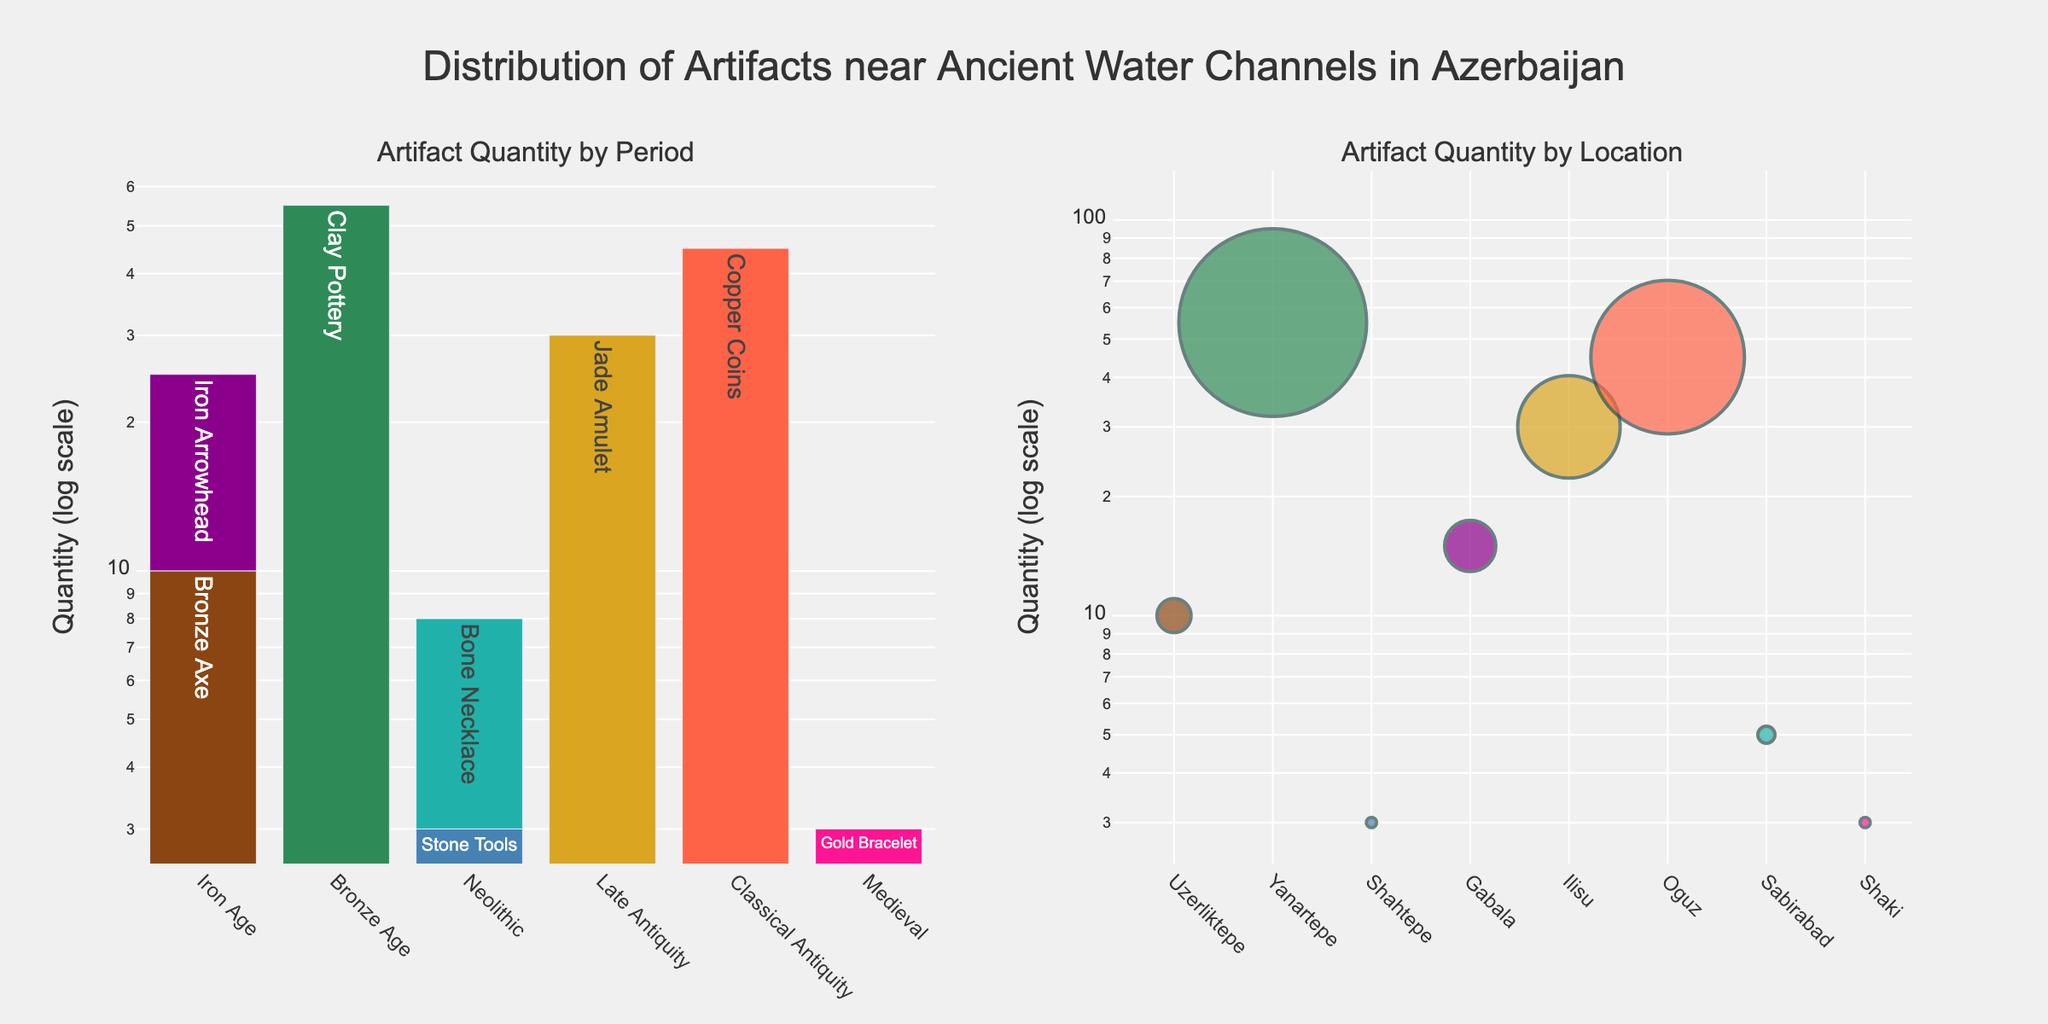What's the most common period the artifacts belong to? The highest bar on the left subplot represents the Bronze Age, indicating it has the highest quantity of artifacts.
Answer: Bronze Age Which artifact has the highest quantity? By looking at the bar heights in the left subplot, we can see the Clay Pottery for the Bronze Age period has the highest bar, representing 55 artifacts.
Answer: Clay Pottery How many artifacts were found in Sabirabad? In the right subplot, looking at the marker's size for Sabirabad, we can see the Bone Necklace with a quantity of 5.
Answer: 5 What's the difference in the quantity of artifacts between Uzerliktepe and Gabala? The left subplot shows Uzerliktepe with 10 artifacts and Gabala with 15 artifacts. The difference is 15 - 10.
Answer: 5 Which location had the smallest quantity of artifacts? By identifying the smallest marker size in the right subplot, Shaki has the smallest marker which means the Gold Bracelet in Shaki with a quantity of 3.
Answer: Shaki What is the total quantity of artifacts from the Neolithic and Iron Age periods? Summing up the quantities from the Neolithic and Iron Age periods shown in the left subplot, 3 (Stone Tools) + 5 (Bone Necklace) + 10 (Bronze Axe) + 15 (Iron Arrowhead) = 33.
Answer: 33 Which artifact is represented by the largest marker in the right subplot? The artifact associated with the largest marker (largest circle) in the right subplot is the Clay Pottery in Yanartepe, indicating it has 55 artifacts.
Answer: Clay Pottery How does the quantity of artifacts from the Classical Antiquity period compare to those from the Medieval period? In the left subplot, comparing the bars, Classical Antiquity (Copper Coins) has 45 artifacts while Medieval (Gold Bracelet) has 3 artifacts. Thus, Copper Coins far outnumber the Gold Bracelet.
Answer: Classical Antiquity has more artifacts What is the average quantity of artifacts found in Yanartepe and Shaki? From the right subplot, Yanartepe has 55 artifacts (Clay Pottery) and Shaki has 3 artifacts (Gold Bracelet). Average is (55 + 3) / 2.
Answer: 29 For which periods were only one type of artifact found? By looking at the unique artifacts associated with each period in the left subplot, it's clear that Jade Amulet (Late Antiquity) and Copper Coins (Classical Antiquity) appear once each.
Answer: Late Antiquity and Classical Antiquity 